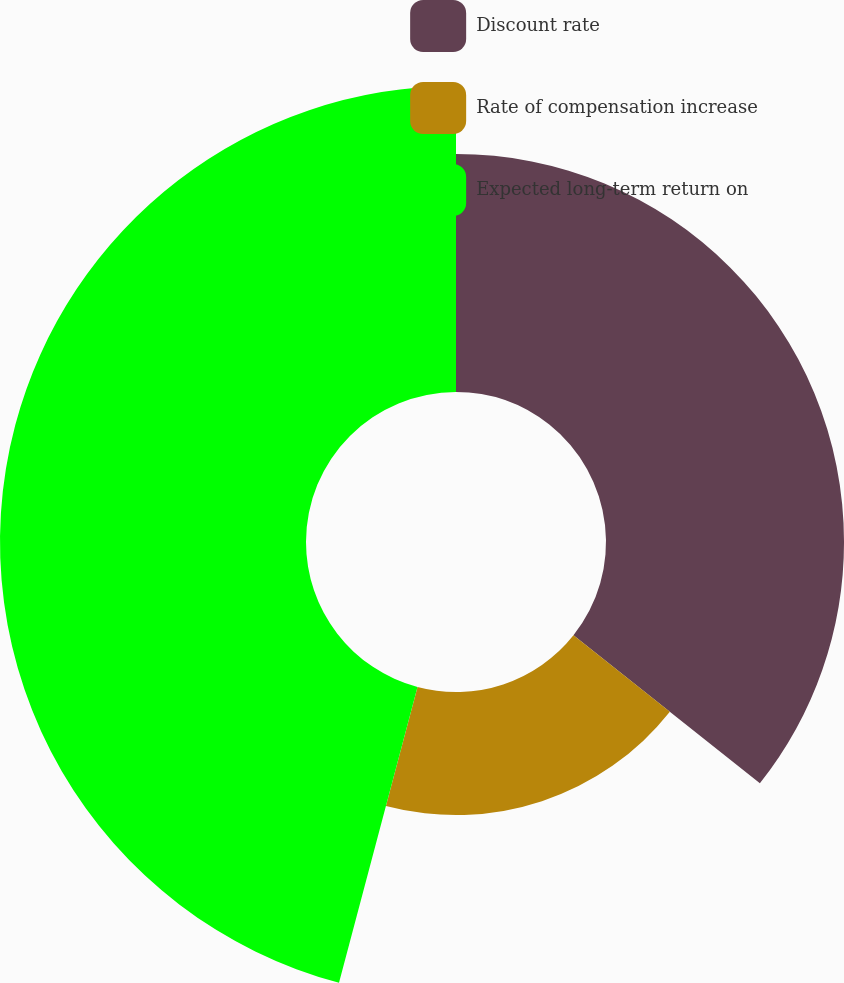<chart> <loc_0><loc_0><loc_500><loc_500><pie_chart><fcel>Discount rate<fcel>Rate of compensation increase<fcel>Expected long-term return on<nl><fcel>35.68%<fcel>18.45%<fcel>45.87%<nl></chart> 